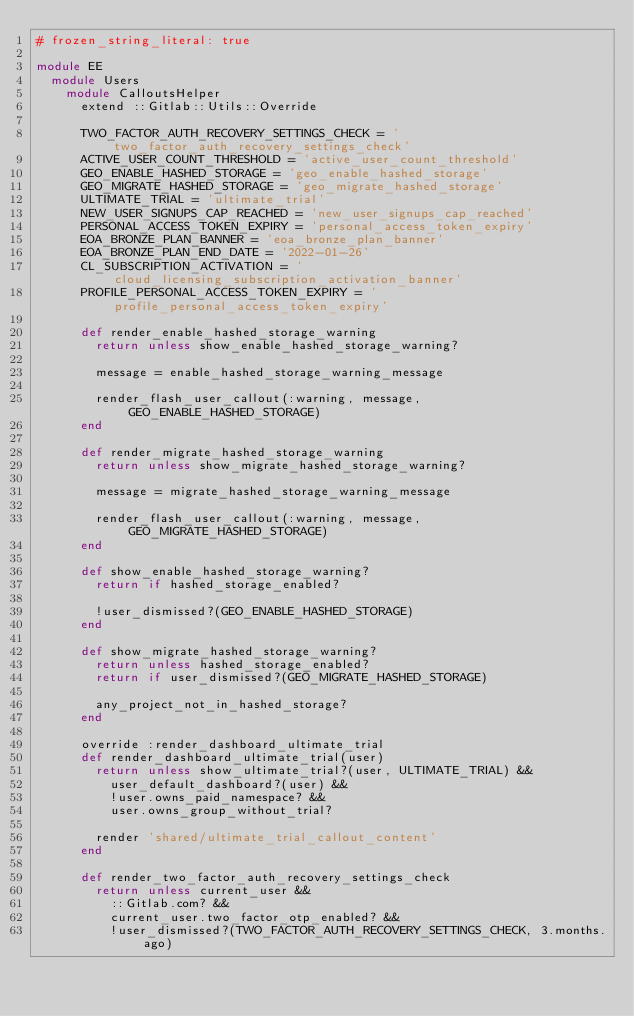<code> <loc_0><loc_0><loc_500><loc_500><_Ruby_># frozen_string_literal: true

module EE
  module Users
    module CalloutsHelper
      extend ::Gitlab::Utils::Override

      TWO_FACTOR_AUTH_RECOVERY_SETTINGS_CHECK = 'two_factor_auth_recovery_settings_check'
      ACTIVE_USER_COUNT_THRESHOLD = 'active_user_count_threshold'
      GEO_ENABLE_HASHED_STORAGE = 'geo_enable_hashed_storage'
      GEO_MIGRATE_HASHED_STORAGE = 'geo_migrate_hashed_storage'
      ULTIMATE_TRIAL = 'ultimate_trial'
      NEW_USER_SIGNUPS_CAP_REACHED = 'new_user_signups_cap_reached'
      PERSONAL_ACCESS_TOKEN_EXPIRY = 'personal_access_token_expiry'
      EOA_BRONZE_PLAN_BANNER = 'eoa_bronze_plan_banner'
      EOA_BRONZE_PLAN_END_DATE = '2022-01-26'
      CL_SUBSCRIPTION_ACTIVATION = 'cloud_licensing_subscription_activation_banner'
      PROFILE_PERSONAL_ACCESS_TOKEN_EXPIRY = 'profile_personal_access_token_expiry'

      def render_enable_hashed_storage_warning
        return unless show_enable_hashed_storage_warning?

        message = enable_hashed_storage_warning_message

        render_flash_user_callout(:warning, message, GEO_ENABLE_HASHED_STORAGE)
      end

      def render_migrate_hashed_storage_warning
        return unless show_migrate_hashed_storage_warning?

        message = migrate_hashed_storage_warning_message

        render_flash_user_callout(:warning, message, GEO_MIGRATE_HASHED_STORAGE)
      end

      def show_enable_hashed_storage_warning?
        return if hashed_storage_enabled?

        !user_dismissed?(GEO_ENABLE_HASHED_STORAGE)
      end

      def show_migrate_hashed_storage_warning?
        return unless hashed_storage_enabled?
        return if user_dismissed?(GEO_MIGRATE_HASHED_STORAGE)

        any_project_not_in_hashed_storage?
      end

      override :render_dashboard_ultimate_trial
      def render_dashboard_ultimate_trial(user)
        return unless show_ultimate_trial?(user, ULTIMATE_TRIAL) &&
          user_default_dashboard?(user) &&
          !user.owns_paid_namespace? &&
          user.owns_group_without_trial?

        render 'shared/ultimate_trial_callout_content'
      end

      def render_two_factor_auth_recovery_settings_check
        return unless current_user &&
          ::Gitlab.com? &&
          current_user.two_factor_otp_enabled? &&
          !user_dismissed?(TWO_FACTOR_AUTH_RECOVERY_SETTINGS_CHECK, 3.months.ago)
</code> 